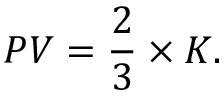Convert formula to latex. <formula><loc_0><loc_0><loc_500><loc_500>P V = { \frac { 2 } { 3 } } \times { K } .</formula> 